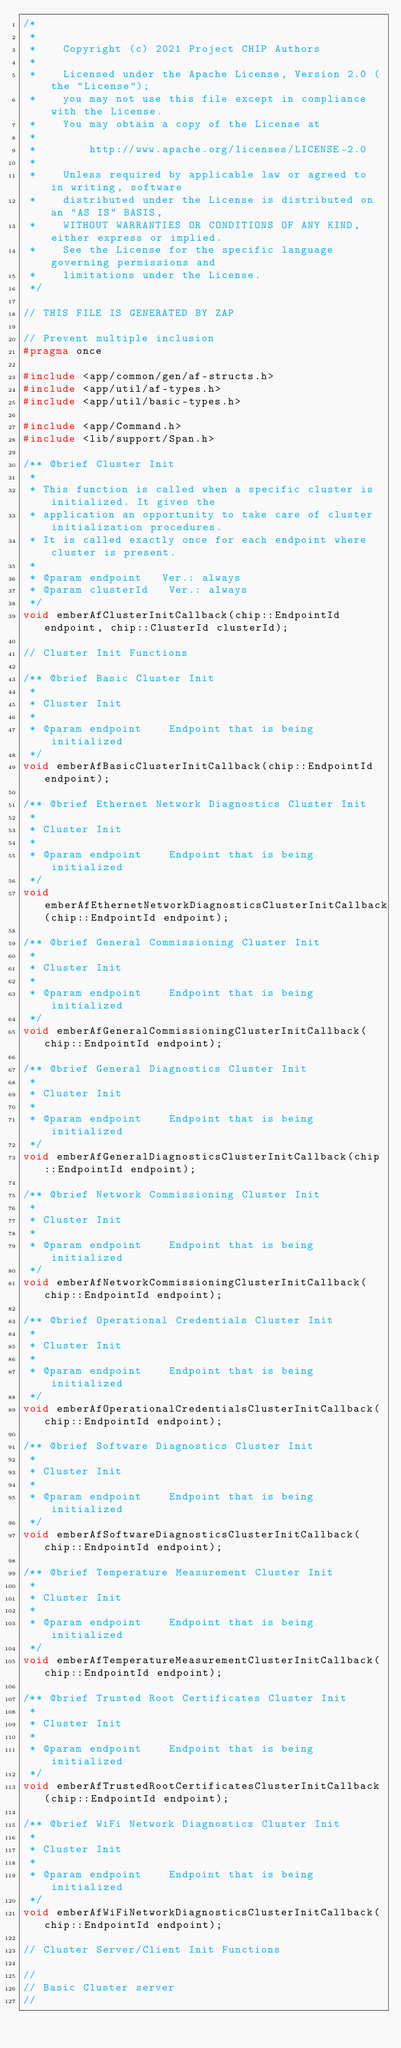<code> <loc_0><loc_0><loc_500><loc_500><_C_>/*
 *
 *    Copyright (c) 2021 Project CHIP Authors
 *
 *    Licensed under the Apache License, Version 2.0 (the "License");
 *    you may not use this file except in compliance with the License.
 *    You may obtain a copy of the License at
 *
 *        http://www.apache.org/licenses/LICENSE-2.0
 *
 *    Unless required by applicable law or agreed to in writing, software
 *    distributed under the License is distributed on an "AS IS" BASIS,
 *    WITHOUT WARRANTIES OR CONDITIONS OF ANY KIND, either express or implied.
 *    See the License for the specific language governing permissions and
 *    limitations under the License.
 */

// THIS FILE IS GENERATED BY ZAP

// Prevent multiple inclusion
#pragma once

#include <app/common/gen/af-structs.h>
#include <app/util/af-types.h>
#include <app/util/basic-types.h>

#include <app/Command.h>
#include <lib/support/Span.h>

/** @brief Cluster Init
 *
 * This function is called when a specific cluster is initialized. It gives the
 * application an opportunity to take care of cluster initialization procedures.
 * It is called exactly once for each endpoint where cluster is present.
 *
 * @param endpoint   Ver.: always
 * @param clusterId   Ver.: always
 */
void emberAfClusterInitCallback(chip::EndpointId endpoint, chip::ClusterId clusterId);

// Cluster Init Functions

/** @brief Basic Cluster Init
 *
 * Cluster Init
 *
 * @param endpoint    Endpoint that is being initialized
 */
void emberAfBasicClusterInitCallback(chip::EndpointId endpoint);

/** @brief Ethernet Network Diagnostics Cluster Init
 *
 * Cluster Init
 *
 * @param endpoint    Endpoint that is being initialized
 */
void emberAfEthernetNetworkDiagnosticsClusterInitCallback(chip::EndpointId endpoint);

/** @brief General Commissioning Cluster Init
 *
 * Cluster Init
 *
 * @param endpoint    Endpoint that is being initialized
 */
void emberAfGeneralCommissioningClusterInitCallback(chip::EndpointId endpoint);

/** @brief General Diagnostics Cluster Init
 *
 * Cluster Init
 *
 * @param endpoint    Endpoint that is being initialized
 */
void emberAfGeneralDiagnosticsClusterInitCallback(chip::EndpointId endpoint);

/** @brief Network Commissioning Cluster Init
 *
 * Cluster Init
 *
 * @param endpoint    Endpoint that is being initialized
 */
void emberAfNetworkCommissioningClusterInitCallback(chip::EndpointId endpoint);

/** @brief Operational Credentials Cluster Init
 *
 * Cluster Init
 *
 * @param endpoint    Endpoint that is being initialized
 */
void emberAfOperationalCredentialsClusterInitCallback(chip::EndpointId endpoint);

/** @brief Software Diagnostics Cluster Init
 *
 * Cluster Init
 *
 * @param endpoint    Endpoint that is being initialized
 */
void emberAfSoftwareDiagnosticsClusterInitCallback(chip::EndpointId endpoint);

/** @brief Temperature Measurement Cluster Init
 *
 * Cluster Init
 *
 * @param endpoint    Endpoint that is being initialized
 */
void emberAfTemperatureMeasurementClusterInitCallback(chip::EndpointId endpoint);

/** @brief Trusted Root Certificates Cluster Init
 *
 * Cluster Init
 *
 * @param endpoint    Endpoint that is being initialized
 */
void emberAfTrustedRootCertificatesClusterInitCallback(chip::EndpointId endpoint);

/** @brief WiFi Network Diagnostics Cluster Init
 *
 * Cluster Init
 *
 * @param endpoint    Endpoint that is being initialized
 */
void emberAfWiFiNetworkDiagnosticsClusterInitCallback(chip::EndpointId endpoint);

// Cluster Server/Client Init Functions

//
// Basic Cluster server
//
</code> 